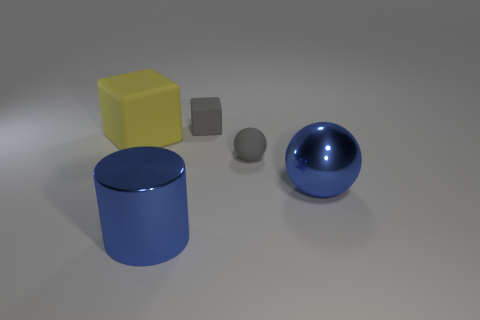What is the size of the sphere that is the same material as the big yellow object?
Provide a short and direct response. Small. What is the color of the object that is in front of the big yellow object and behind the big metallic ball?
Give a very brief answer. Gray. What number of gray matte cubes are the same size as the yellow matte block?
Ensure brevity in your answer.  0. What size is the block that is the same color as the small rubber sphere?
Keep it short and to the point. Small. How big is the rubber thing that is left of the small ball and to the right of the big block?
Offer a terse response. Small. What number of big objects are in front of the sphere behind the blue thing that is to the right of the large metallic cylinder?
Provide a short and direct response. 2. Are there any tiny rubber balls of the same color as the small block?
Keep it short and to the point. Yes. What color is the thing that is the same size as the gray rubber cube?
Give a very brief answer. Gray. There is a large blue object on the left side of the rubber object that is on the right side of the tiny gray matte object that is behind the yellow cube; what is its shape?
Make the answer very short. Cylinder. How many blocks are in front of the small thing that is behind the yellow rubber thing?
Make the answer very short. 1. 